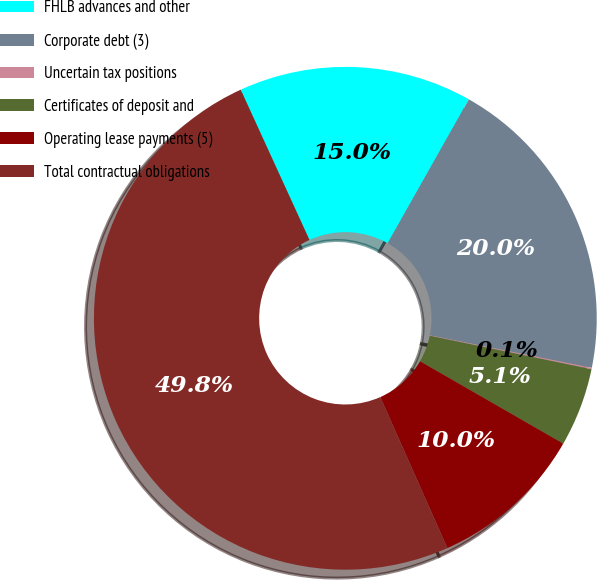Convert chart to OTSL. <chart><loc_0><loc_0><loc_500><loc_500><pie_chart><fcel>FHLB advances and other<fcel>Corporate debt (3)<fcel>Uncertain tax positions<fcel>Certificates of deposit and<fcel>Operating lease payments (5)<fcel>Total contractual obligations<nl><fcel>15.01%<fcel>19.98%<fcel>0.09%<fcel>5.06%<fcel>10.04%<fcel>49.82%<nl></chart> 